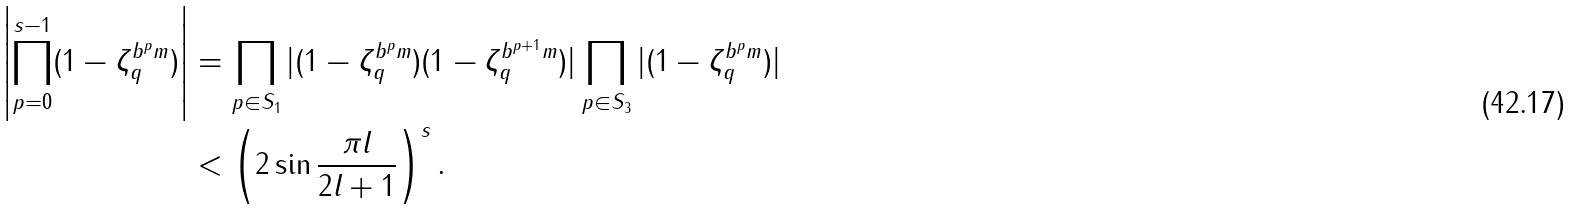Convert formula to latex. <formula><loc_0><loc_0><loc_500><loc_500>\left | \prod _ { p = 0 } ^ { s - 1 } ( 1 - \zeta _ { q } ^ { b ^ { p } m } ) \right | & = \prod _ { p \in S _ { 1 } } | ( 1 - \zeta _ { q } ^ { b ^ { p } m } ) ( 1 - \zeta _ { q } ^ { b ^ { p + 1 } m } ) | \prod _ { p \in S _ { 3 } } | ( 1 - \zeta _ { q } ^ { b ^ { p } m } ) | \\ & < \left ( 2 \sin \frac { \pi l } { 2 l + 1 } \right ) ^ { s } .</formula> 